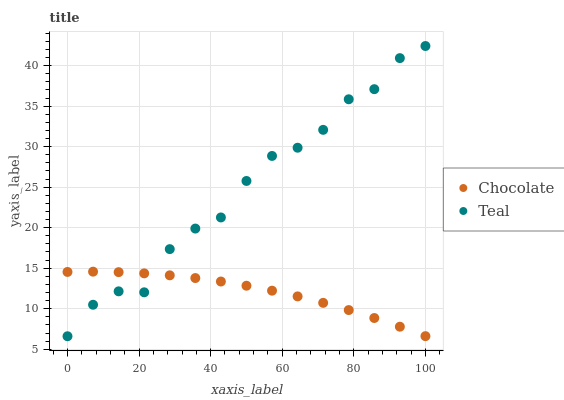Does Chocolate have the minimum area under the curve?
Answer yes or no. Yes. Does Teal have the maximum area under the curve?
Answer yes or no. Yes. Does Chocolate have the maximum area under the curve?
Answer yes or no. No. Is Chocolate the smoothest?
Answer yes or no. Yes. Is Teal the roughest?
Answer yes or no. Yes. Is Chocolate the roughest?
Answer yes or no. No. Does Teal have the lowest value?
Answer yes or no. Yes. Does Chocolate have the lowest value?
Answer yes or no. No. Does Teal have the highest value?
Answer yes or no. Yes. Does Chocolate have the highest value?
Answer yes or no. No. Does Teal intersect Chocolate?
Answer yes or no. Yes. Is Teal less than Chocolate?
Answer yes or no. No. Is Teal greater than Chocolate?
Answer yes or no. No. 